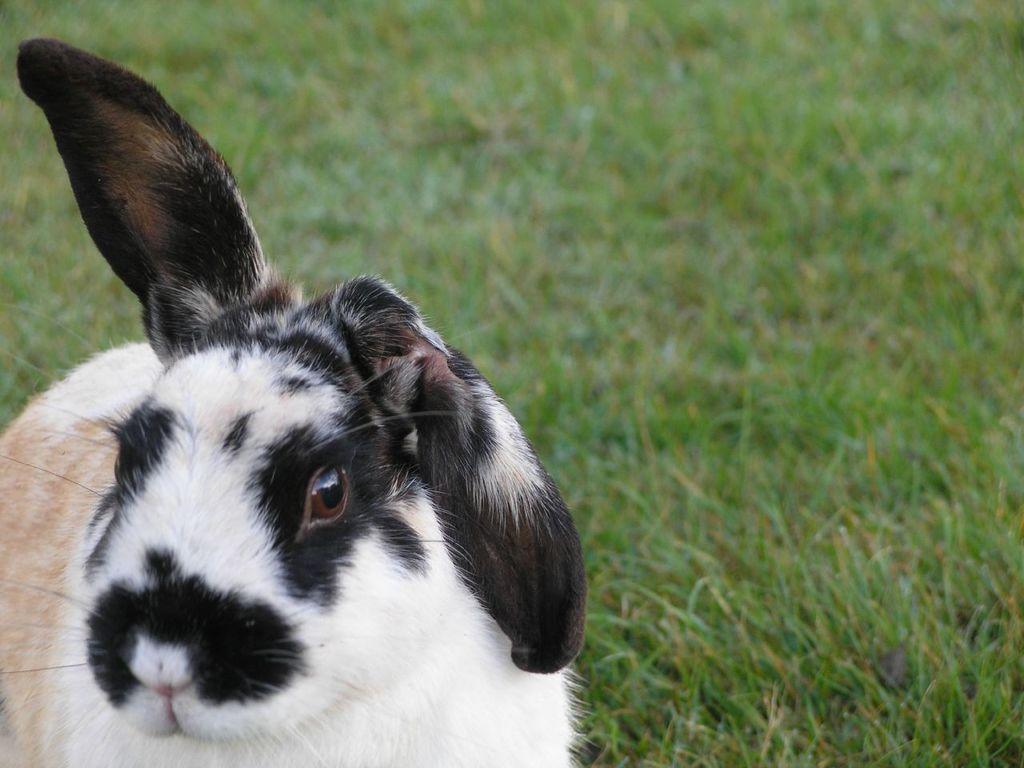How would you summarize this image in a sentence or two? In this image I can see an animal which is black, white and cream in color is on the grass. In the background I can see the grass. 